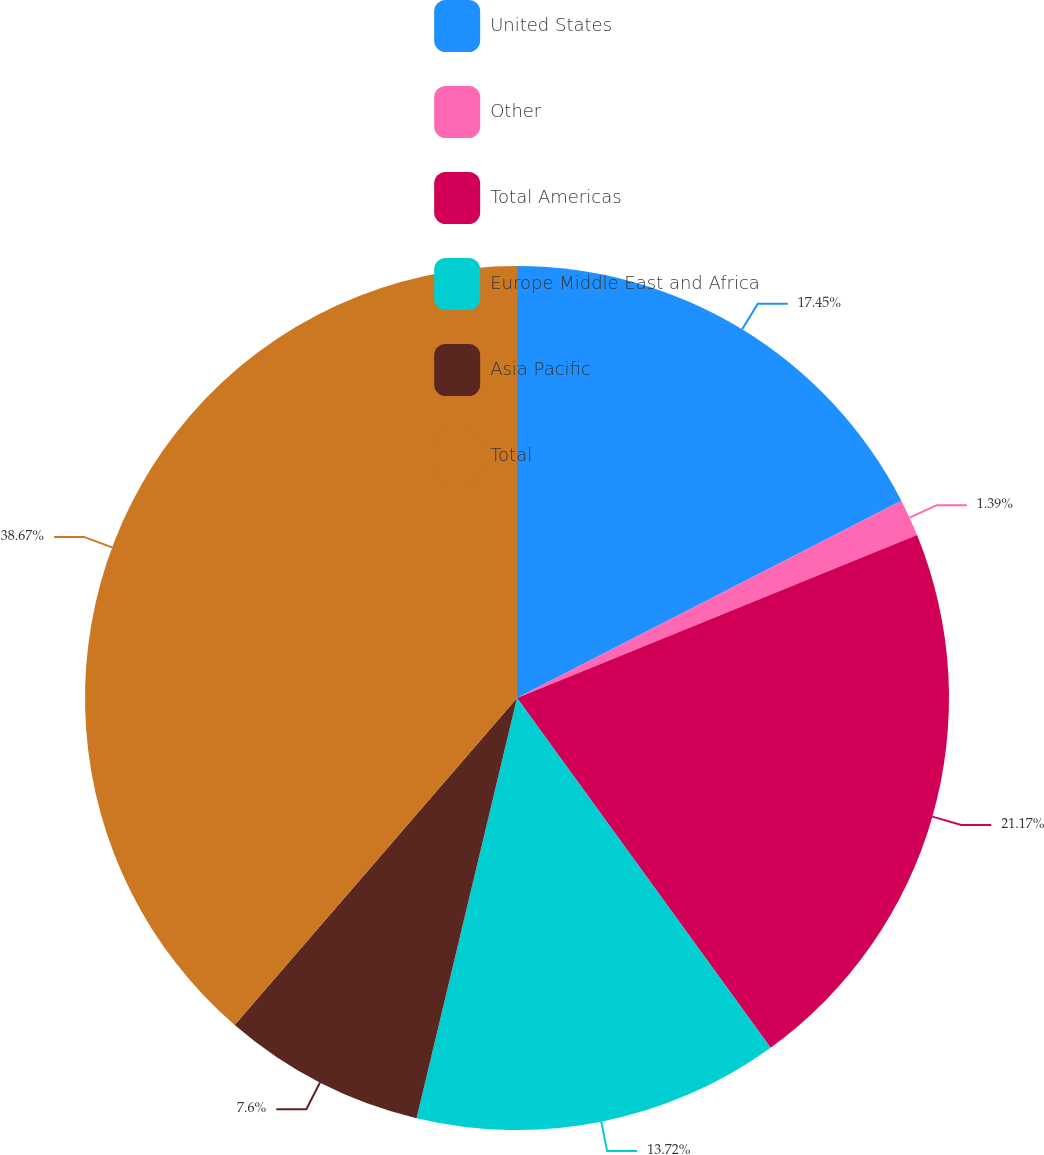<chart> <loc_0><loc_0><loc_500><loc_500><pie_chart><fcel>United States<fcel>Other<fcel>Total Americas<fcel>Europe Middle East and Africa<fcel>Asia Pacific<fcel>Total<nl><fcel>17.45%<fcel>1.39%<fcel>21.17%<fcel>13.72%<fcel>7.6%<fcel>38.66%<nl></chart> 